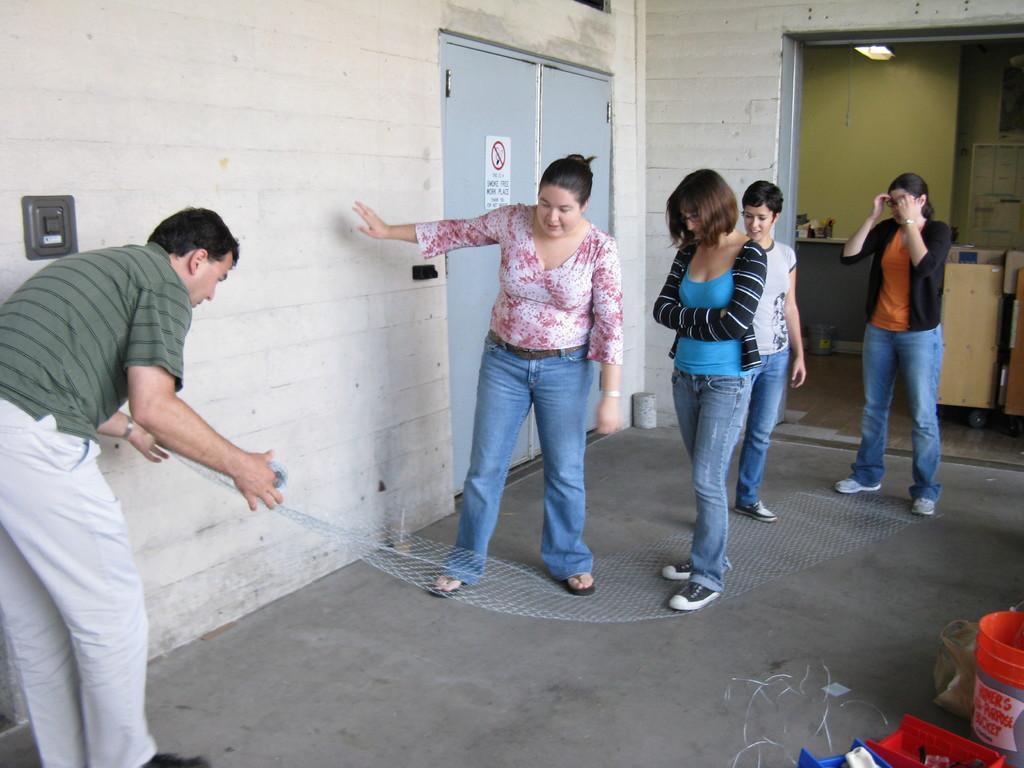Could you give a brief overview of what you see in this image? This image is taken indoors. At the bottom of the image there is a floor. In the background there is a wall with a door. On the left side of the image a man is standing on the floor and he is holding a net roll in his hands. In the middle of the image four women are standing on the floor. In the background there are a few things. On the right side of the image there is a bucket and a few things on the floor. 